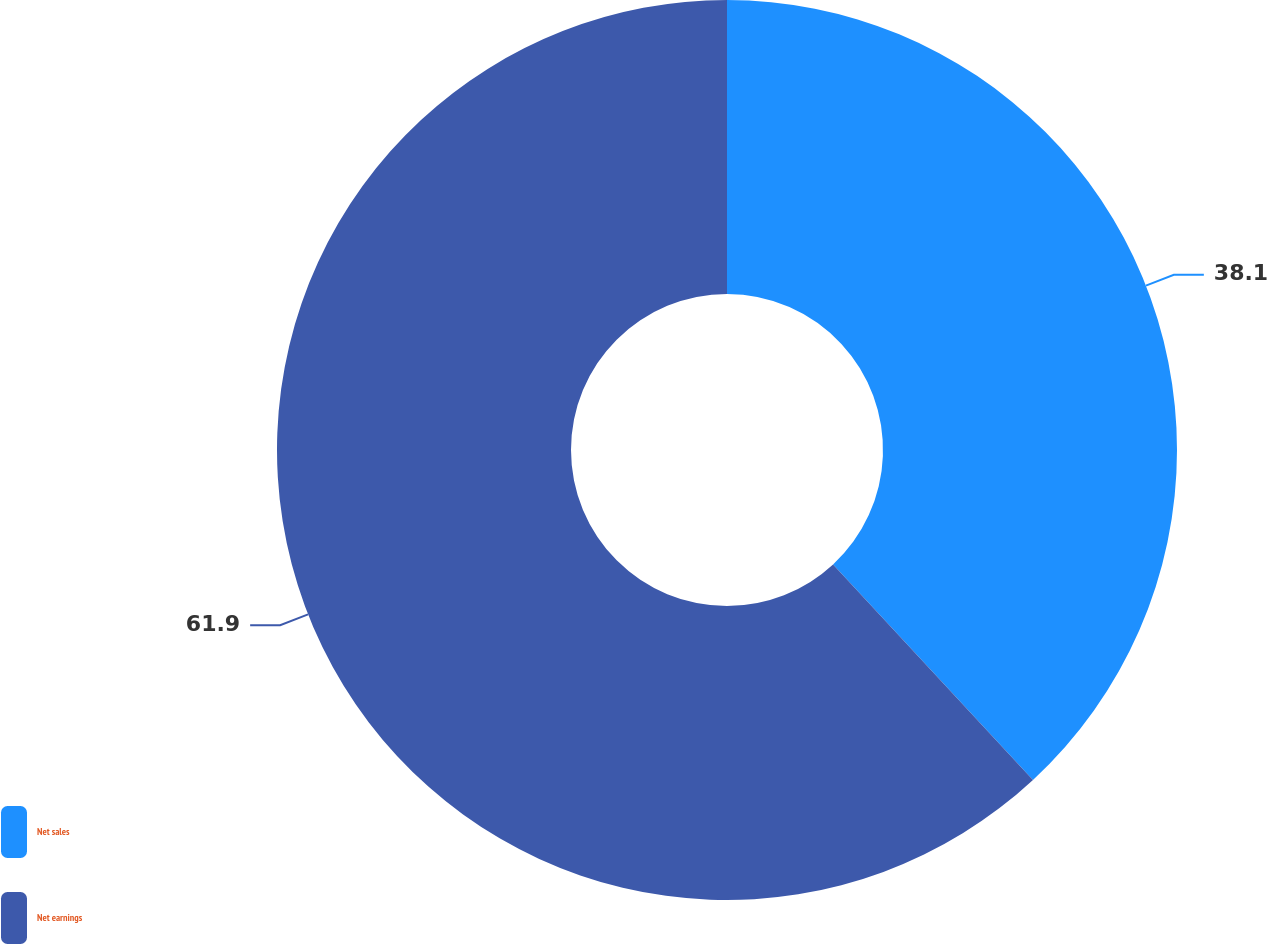Convert chart. <chart><loc_0><loc_0><loc_500><loc_500><pie_chart><fcel>Net sales<fcel>Net earnings<nl><fcel>38.1%<fcel>61.9%<nl></chart> 